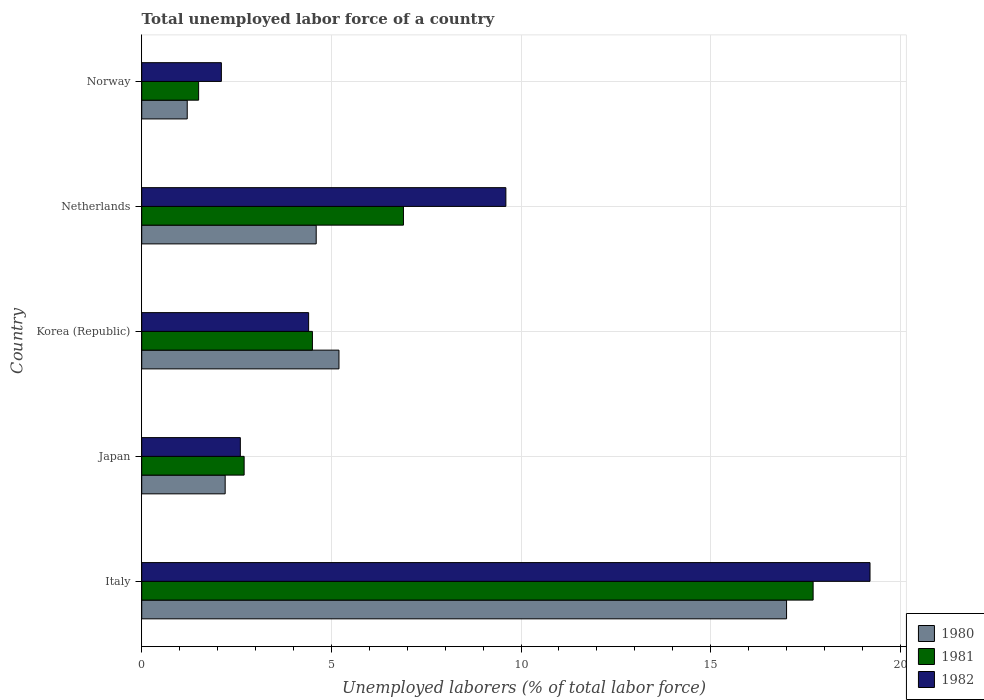How many different coloured bars are there?
Offer a very short reply. 3. How many groups of bars are there?
Give a very brief answer. 5. How many bars are there on the 4th tick from the top?
Your response must be concise. 3. In how many cases, is the number of bars for a given country not equal to the number of legend labels?
Ensure brevity in your answer.  0. What is the total unemployed labor force in 1982 in Japan?
Ensure brevity in your answer.  2.6. Across all countries, what is the maximum total unemployed labor force in 1981?
Your response must be concise. 17.7. Across all countries, what is the minimum total unemployed labor force in 1980?
Make the answer very short. 1.2. In which country was the total unemployed labor force in 1982 maximum?
Offer a terse response. Italy. In which country was the total unemployed labor force in 1981 minimum?
Offer a very short reply. Norway. What is the total total unemployed labor force in 1980 in the graph?
Ensure brevity in your answer.  30.2. What is the difference between the total unemployed labor force in 1981 in Netherlands and that in Norway?
Your answer should be very brief. 5.4. What is the difference between the total unemployed labor force in 1982 in Italy and the total unemployed labor force in 1981 in Japan?
Keep it short and to the point. 16.5. What is the average total unemployed labor force in 1982 per country?
Offer a terse response. 7.58. What is the difference between the total unemployed labor force in 1980 and total unemployed labor force in 1982 in Italy?
Your answer should be compact. -2.2. In how many countries, is the total unemployed labor force in 1981 greater than 13 %?
Make the answer very short. 1. What is the ratio of the total unemployed labor force in 1980 in Korea (Republic) to that in Netherlands?
Your answer should be compact. 1.13. Is the difference between the total unemployed labor force in 1980 in Korea (Republic) and Netherlands greater than the difference between the total unemployed labor force in 1982 in Korea (Republic) and Netherlands?
Provide a short and direct response. Yes. What is the difference between the highest and the second highest total unemployed labor force in 1981?
Give a very brief answer. 10.8. What is the difference between the highest and the lowest total unemployed labor force in 1981?
Ensure brevity in your answer.  16.2. In how many countries, is the total unemployed labor force in 1980 greater than the average total unemployed labor force in 1980 taken over all countries?
Provide a short and direct response. 1. Is the sum of the total unemployed labor force in 1980 in Netherlands and Norway greater than the maximum total unemployed labor force in 1982 across all countries?
Make the answer very short. No. How many bars are there?
Your response must be concise. 15. What is the difference between two consecutive major ticks on the X-axis?
Your response must be concise. 5. Are the values on the major ticks of X-axis written in scientific E-notation?
Your response must be concise. No. Does the graph contain grids?
Offer a terse response. Yes. How many legend labels are there?
Make the answer very short. 3. How are the legend labels stacked?
Ensure brevity in your answer.  Vertical. What is the title of the graph?
Keep it short and to the point. Total unemployed labor force of a country. Does "1986" appear as one of the legend labels in the graph?
Your answer should be compact. No. What is the label or title of the X-axis?
Ensure brevity in your answer.  Unemployed laborers (% of total labor force). What is the Unemployed laborers (% of total labor force) of 1981 in Italy?
Ensure brevity in your answer.  17.7. What is the Unemployed laborers (% of total labor force) of 1982 in Italy?
Your answer should be very brief. 19.2. What is the Unemployed laborers (% of total labor force) of 1980 in Japan?
Keep it short and to the point. 2.2. What is the Unemployed laborers (% of total labor force) of 1981 in Japan?
Give a very brief answer. 2.7. What is the Unemployed laborers (% of total labor force) in 1982 in Japan?
Give a very brief answer. 2.6. What is the Unemployed laborers (% of total labor force) of 1980 in Korea (Republic)?
Offer a very short reply. 5.2. What is the Unemployed laborers (% of total labor force) of 1982 in Korea (Republic)?
Provide a short and direct response. 4.4. What is the Unemployed laborers (% of total labor force) of 1980 in Netherlands?
Your answer should be very brief. 4.6. What is the Unemployed laborers (% of total labor force) of 1981 in Netherlands?
Your response must be concise. 6.9. What is the Unemployed laborers (% of total labor force) in 1982 in Netherlands?
Your answer should be very brief. 9.6. What is the Unemployed laborers (% of total labor force) of 1980 in Norway?
Provide a succinct answer. 1.2. What is the Unemployed laborers (% of total labor force) of 1981 in Norway?
Your response must be concise. 1.5. What is the Unemployed laborers (% of total labor force) in 1982 in Norway?
Make the answer very short. 2.1. Across all countries, what is the maximum Unemployed laborers (% of total labor force) in 1980?
Provide a succinct answer. 17. Across all countries, what is the maximum Unemployed laborers (% of total labor force) of 1981?
Make the answer very short. 17.7. Across all countries, what is the maximum Unemployed laborers (% of total labor force) of 1982?
Keep it short and to the point. 19.2. Across all countries, what is the minimum Unemployed laborers (% of total labor force) of 1980?
Keep it short and to the point. 1.2. Across all countries, what is the minimum Unemployed laborers (% of total labor force) of 1981?
Ensure brevity in your answer.  1.5. Across all countries, what is the minimum Unemployed laborers (% of total labor force) of 1982?
Offer a terse response. 2.1. What is the total Unemployed laborers (% of total labor force) of 1980 in the graph?
Give a very brief answer. 30.2. What is the total Unemployed laborers (% of total labor force) in 1981 in the graph?
Offer a very short reply. 33.3. What is the total Unemployed laborers (% of total labor force) of 1982 in the graph?
Ensure brevity in your answer.  37.9. What is the difference between the Unemployed laborers (% of total labor force) of 1980 in Italy and that in Japan?
Make the answer very short. 14.8. What is the difference between the Unemployed laborers (% of total labor force) of 1982 in Italy and that in Japan?
Give a very brief answer. 16.6. What is the difference between the Unemployed laborers (% of total labor force) in 1980 in Italy and that in Korea (Republic)?
Your answer should be compact. 11.8. What is the difference between the Unemployed laborers (% of total labor force) of 1981 in Italy and that in Korea (Republic)?
Your response must be concise. 13.2. What is the difference between the Unemployed laborers (% of total labor force) in 1980 in Italy and that in Netherlands?
Provide a succinct answer. 12.4. What is the difference between the Unemployed laborers (% of total labor force) of 1981 in Italy and that in Netherlands?
Give a very brief answer. 10.8. What is the difference between the Unemployed laborers (% of total labor force) of 1982 in Italy and that in Netherlands?
Your answer should be compact. 9.6. What is the difference between the Unemployed laborers (% of total labor force) of 1980 in Italy and that in Norway?
Make the answer very short. 15.8. What is the difference between the Unemployed laborers (% of total labor force) in 1981 in Italy and that in Norway?
Give a very brief answer. 16.2. What is the difference between the Unemployed laborers (% of total labor force) in 1980 in Japan and that in Korea (Republic)?
Give a very brief answer. -3. What is the difference between the Unemployed laborers (% of total labor force) in 1981 in Japan and that in Korea (Republic)?
Make the answer very short. -1.8. What is the difference between the Unemployed laborers (% of total labor force) in 1982 in Japan and that in Netherlands?
Make the answer very short. -7. What is the difference between the Unemployed laborers (% of total labor force) of 1980 in Japan and that in Norway?
Keep it short and to the point. 1. What is the difference between the Unemployed laborers (% of total labor force) in 1981 in Japan and that in Norway?
Offer a very short reply. 1.2. What is the difference between the Unemployed laborers (% of total labor force) in 1982 in Japan and that in Norway?
Provide a short and direct response. 0.5. What is the difference between the Unemployed laborers (% of total labor force) of 1981 in Korea (Republic) and that in Netherlands?
Ensure brevity in your answer.  -2.4. What is the difference between the Unemployed laborers (% of total labor force) of 1980 in Korea (Republic) and that in Norway?
Your response must be concise. 4. What is the difference between the Unemployed laborers (% of total labor force) in 1981 in Korea (Republic) and that in Norway?
Ensure brevity in your answer.  3. What is the difference between the Unemployed laborers (% of total labor force) in 1982 in Korea (Republic) and that in Norway?
Provide a short and direct response. 2.3. What is the difference between the Unemployed laborers (% of total labor force) in 1980 in Netherlands and that in Norway?
Give a very brief answer. 3.4. What is the difference between the Unemployed laborers (% of total labor force) of 1981 in Netherlands and that in Norway?
Make the answer very short. 5.4. What is the difference between the Unemployed laborers (% of total labor force) in 1982 in Netherlands and that in Norway?
Offer a very short reply. 7.5. What is the difference between the Unemployed laborers (% of total labor force) in 1980 in Italy and the Unemployed laborers (% of total labor force) in 1982 in Japan?
Offer a terse response. 14.4. What is the difference between the Unemployed laborers (% of total labor force) in 1980 in Italy and the Unemployed laborers (% of total labor force) in 1981 in Korea (Republic)?
Offer a very short reply. 12.5. What is the difference between the Unemployed laborers (% of total labor force) in 1980 in Italy and the Unemployed laborers (% of total labor force) in 1982 in Korea (Republic)?
Ensure brevity in your answer.  12.6. What is the difference between the Unemployed laborers (% of total labor force) in 1981 in Italy and the Unemployed laborers (% of total labor force) in 1982 in Korea (Republic)?
Provide a short and direct response. 13.3. What is the difference between the Unemployed laborers (% of total labor force) in 1980 in Italy and the Unemployed laborers (% of total labor force) in 1981 in Netherlands?
Ensure brevity in your answer.  10.1. What is the difference between the Unemployed laborers (% of total labor force) of 1980 in Italy and the Unemployed laborers (% of total labor force) of 1982 in Netherlands?
Give a very brief answer. 7.4. What is the difference between the Unemployed laborers (% of total labor force) of 1980 in Italy and the Unemployed laborers (% of total labor force) of 1981 in Norway?
Provide a succinct answer. 15.5. What is the difference between the Unemployed laborers (% of total labor force) of 1980 in Italy and the Unemployed laborers (% of total labor force) of 1982 in Norway?
Provide a succinct answer. 14.9. What is the difference between the Unemployed laborers (% of total labor force) in 1981 in Italy and the Unemployed laborers (% of total labor force) in 1982 in Norway?
Offer a terse response. 15.6. What is the difference between the Unemployed laborers (% of total labor force) in 1980 in Japan and the Unemployed laborers (% of total labor force) in 1981 in Korea (Republic)?
Your answer should be compact. -2.3. What is the difference between the Unemployed laborers (% of total labor force) in 1980 in Japan and the Unemployed laborers (% of total labor force) in 1982 in Korea (Republic)?
Keep it short and to the point. -2.2. What is the difference between the Unemployed laborers (% of total labor force) in 1981 in Japan and the Unemployed laborers (% of total labor force) in 1982 in Korea (Republic)?
Give a very brief answer. -1.7. What is the difference between the Unemployed laborers (% of total labor force) in 1980 in Japan and the Unemployed laborers (% of total labor force) in 1982 in Netherlands?
Give a very brief answer. -7.4. What is the difference between the Unemployed laborers (% of total labor force) in 1980 in Japan and the Unemployed laborers (% of total labor force) in 1981 in Norway?
Offer a very short reply. 0.7. What is the difference between the Unemployed laborers (% of total labor force) in 1980 in Japan and the Unemployed laborers (% of total labor force) in 1982 in Norway?
Provide a short and direct response. 0.1. What is the difference between the Unemployed laborers (% of total labor force) in 1980 in Korea (Republic) and the Unemployed laborers (% of total labor force) in 1982 in Netherlands?
Your response must be concise. -4.4. What is the difference between the Unemployed laborers (% of total labor force) in 1981 in Korea (Republic) and the Unemployed laborers (% of total labor force) in 1982 in Netherlands?
Your answer should be very brief. -5.1. What is the difference between the Unemployed laborers (% of total labor force) in 1980 in Korea (Republic) and the Unemployed laborers (% of total labor force) in 1981 in Norway?
Ensure brevity in your answer.  3.7. What is the difference between the Unemployed laborers (% of total labor force) of 1981 in Netherlands and the Unemployed laborers (% of total labor force) of 1982 in Norway?
Your answer should be compact. 4.8. What is the average Unemployed laborers (% of total labor force) of 1980 per country?
Give a very brief answer. 6.04. What is the average Unemployed laborers (% of total labor force) of 1981 per country?
Provide a short and direct response. 6.66. What is the average Unemployed laborers (% of total labor force) in 1982 per country?
Your answer should be very brief. 7.58. What is the difference between the Unemployed laborers (% of total labor force) of 1981 and Unemployed laborers (% of total labor force) of 1982 in Italy?
Your answer should be very brief. -1.5. What is the difference between the Unemployed laborers (% of total labor force) in 1980 and Unemployed laborers (% of total labor force) in 1982 in Japan?
Give a very brief answer. -0.4. What is the difference between the Unemployed laborers (% of total labor force) in 1980 and Unemployed laborers (% of total labor force) in 1981 in Korea (Republic)?
Your answer should be compact. 0.7. What is the difference between the Unemployed laborers (% of total labor force) of 1980 and Unemployed laborers (% of total labor force) of 1982 in Korea (Republic)?
Keep it short and to the point. 0.8. What is the difference between the Unemployed laborers (% of total labor force) of 1981 and Unemployed laborers (% of total labor force) of 1982 in Korea (Republic)?
Provide a succinct answer. 0.1. What is the difference between the Unemployed laborers (% of total labor force) of 1980 and Unemployed laborers (% of total labor force) of 1981 in Netherlands?
Keep it short and to the point. -2.3. What is the difference between the Unemployed laborers (% of total labor force) of 1981 and Unemployed laborers (% of total labor force) of 1982 in Netherlands?
Make the answer very short. -2.7. What is the ratio of the Unemployed laborers (% of total labor force) in 1980 in Italy to that in Japan?
Your response must be concise. 7.73. What is the ratio of the Unemployed laborers (% of total labor force) of 1981 in Italy to that in Japan?
Give a very brief answer. 6.56. What is the ratio of the Unemployed laborers (% of total labor force) in 1982 in Italy to that in Japan?
Make the answer very short. 7.38. What is the ratio of the Unemployed laborers (% of total labor force) in 1980 in Italy to that in Korea (Republic)?
Offer a terse response. 3.27. What is the ratio of the Unemployed laborers (% of total labor force) of 1981 in Italy to that in Korea (Republic)?
Ensure brevity in your answer.  3.93. What is the ratio of the Unemployed laborers (% of total labor force) of 1982 in Italy to that in Korea (Republic)?
Your response must be concise. 4.36. What is the ratio of the Unemployed laborers (% of total labor force) of 1980 in Italy to that in Netherlands?
Your answer should be very brief. 3.7. What is the ratio of the Unemployed laborers (% of total labor force) of 1981 in Italy to that in Netherlands?
Offer a very short reply. 2.57. What is the ratio of the Unemployed laborers (% of total labor force) in 1982 in Italy to that in Netherlands?
Provide a succinct answer. 2. What is the ratio of the Unemployed laborers (% of total labor force) in 1980 in Italy to that in Norway?
Ensure brevity in your answer.  14.17. What is the ratio of the Unemployed laborers (% of total labor force) in 1981 in Italy to that in Norway?
Your answer should be compact. 11.8. What is the ratio of the Unemployed laborers (% of total labor force) of 1982 in Italy to that in Norway?
Provide a succinct answer. 9.14. What is the ratio of the Unemployed laborers (% of total labor force) in 1980 in Japan to that in Korea (Republic)?
Your response must be concise. 0.42. What is the ratio of the Unemployed laborers (% of total labor force) of 1981 in Japan to that in Korea (Republic)?
Offer a very short reply. 0.6. What is the ratio of the Unemployed laborers (% of total labor force) in 1982 in Japan to that in Korea (Republic)?
Give a very brief answer. 0.59. What is the ratio of the Unemployed laborers (% of total labor force) in 1980 in Japan to that in Netherlands?
Offer a terse response. 0.48. What is the ratio of the Unemployed laborers (% of total labor force) of 1981 in Japan to that in Netherlands?
Your answer should be very brief. 0.39. What is the ratio of the Unemployed laborers (% of total labor force) in 1982 in Japan to that in Netherlands?
Give a very brief answer. 0.27. What is the ratio of the Unemployed laborers (% of total labor force) of 1980 in Japan to that in Norway?
Your response must be concise. 1.83. What is the ratio of the Unemployed laborers (% of total labor force) of 1981 in Japan to that in Norway?
Your response must be concise. 1.8. What is the ratio of the Unemployed laborers (% of total labor force) of 1982 in Japan to that in Norway?
Make the answer very short. 1.24. What is the ratio of the Unemployed laborers (% of total labor force) in 1980 in Korea (Republic) to that in Netherlands?
Your answer should be very brief. 1.13. What is the ratio of the Unemployed laborers (% of total labor force) of 1981 in Korea (Republic) to that in Netherlands?
Your answer should be very brief. 0.65. What is the ratio of the Unemployed laborers (% of total labor force) of 1982 in Korea (Republic) to that in Netherlands?
Your response must be concise. 0.46. What is the ratio of the Unemployed laborers (% of total labor force) of 1980 in Korea (Republic) to that in Norway?
Make the answer very short. 4.33. What is the ratio of the Unemployed laborers (% of total labor force) in 1982 in Korea (Republic) to that in Norway?
Your answer should be compact. 2.1. What is the ratio of the Unemployed laborers (% of total labor force) of 1980 in Netherlands to that in Norway?
Offer a terse response. 3.83. What is the ratio of the Unemployed laborers (% of total labor force) in 1981 in Netherlands to that in Norway?
Offer a terse response. 4.6. What is the ratio of the Unemployed laborers (% of total labor force) of 1982 in Netherlands to that in Norway?
Keep it short and to the point. 4.57. What is the difference between the highest and the second highest Unemployed laborers (% of total labor force) of 1980?
Your answer should be compact. 11.8. What is the difference between the highest and the second highest Unemployed laborers (% of total labor force) of 1981?
Ensure brevity in your answer.  10.8. What is the difference between the highest and the lowest Unemployed laborers (% of total labor force) in 1981?
Make the answer very short. 16.2. 